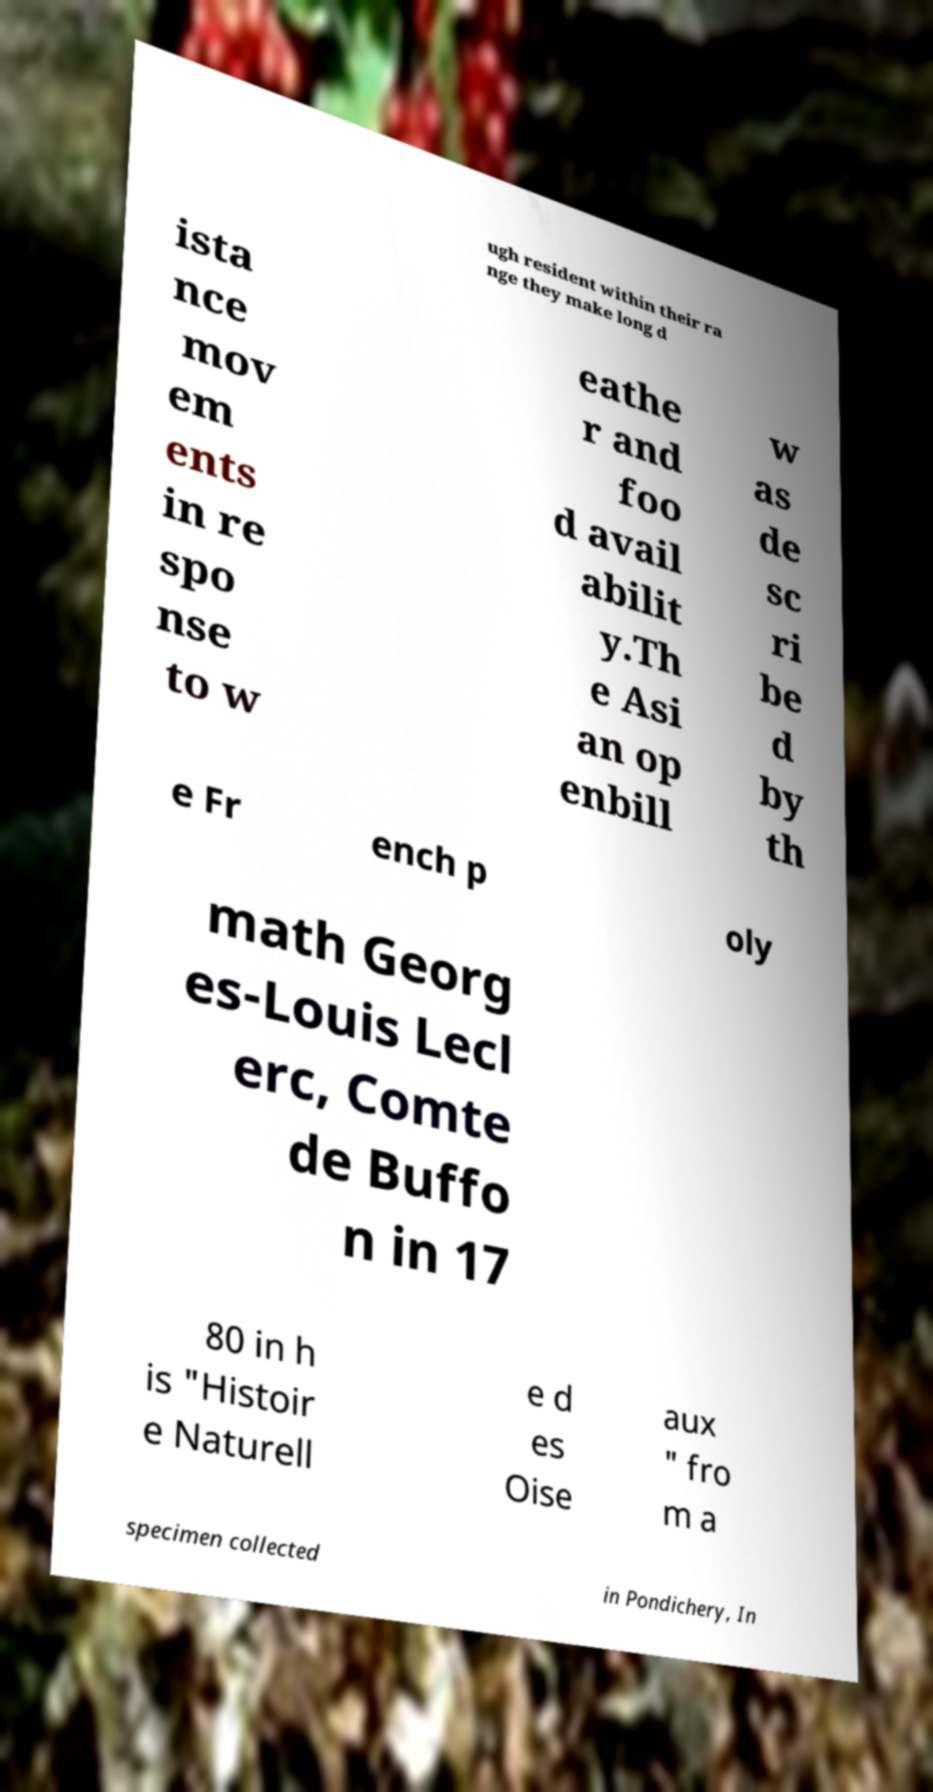Could you extract and type out the text from this image? ugh resident within their ra nge they make long d ista nce mov em ents in re spo nse to w eathe r and foo d avail abilit y.Th e Asi an op enbill w as de sc ri be d by th e Fr ench p oly math Georg es-Louis Lecl erc, Comte de Buffo n in 17 80 in h is "Histoir e Naturell e d es Oise aux " fro m a specimen collected in Pondichery, In 